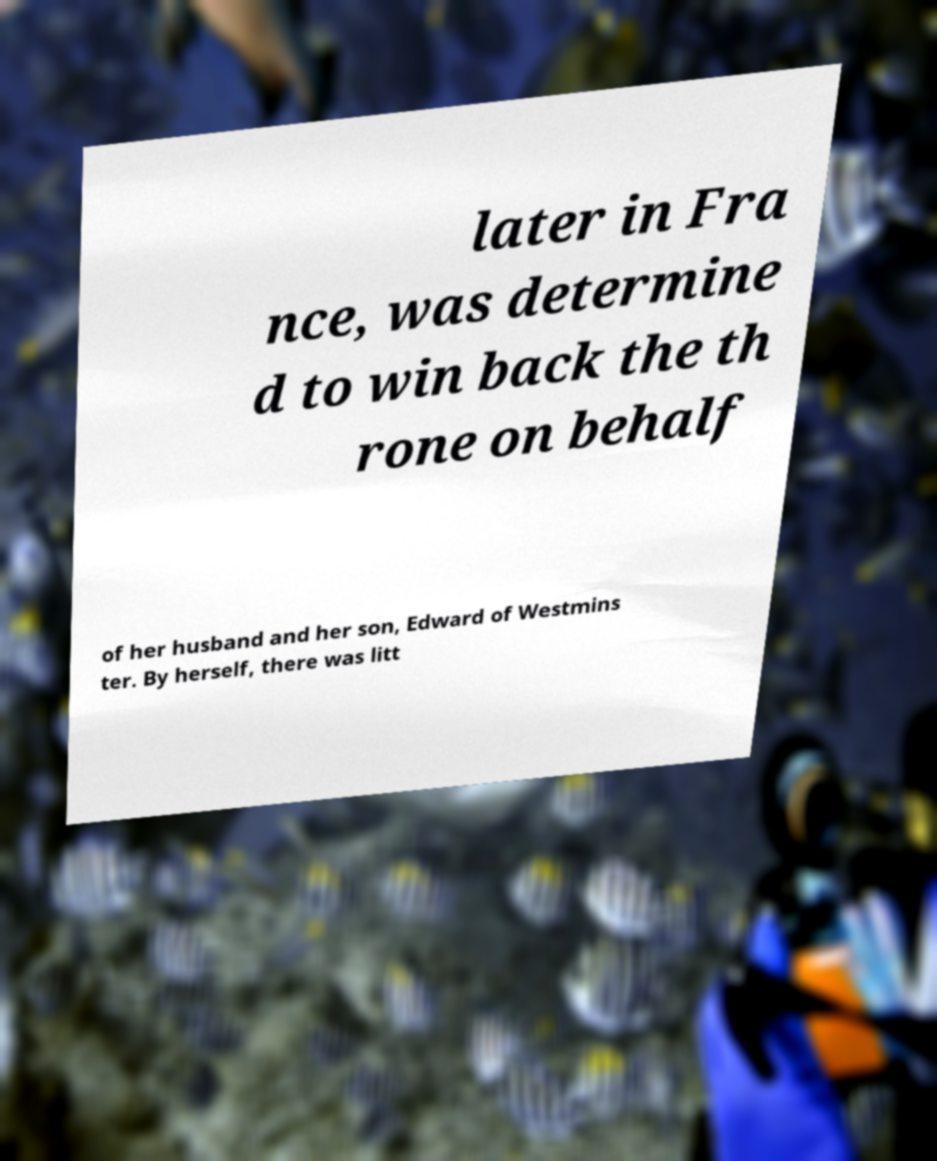Could you assist in decoding the text presented in this image and type it out clearly? later in Fra nce, was determine d to win back the th rone on behalf of her husband and her son, Edward of Westmins ter. By herself, there was litt 